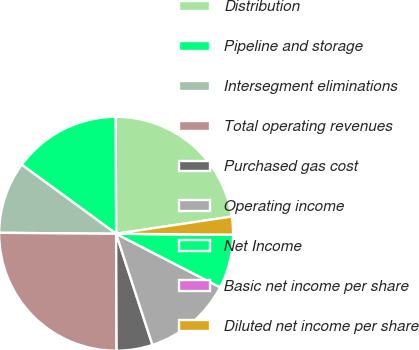<chart> <loc_0><loc_0><loc_500><loc_500><pie_chart><fcel>Distribution<fcel>Pipeline and storage<fcel>Intersegment eliminations<fcel>Total operating revenues<fcel>Purchased gas cost<fcel>Operating income<fcel>Net Income<fcel>Basic net income per share<fcel>Diluted net income per share<nl><fcel>22.72%<fcel>14.88%<fcel>9.92%<fcel>25.2%<fcel>4.96%<fcel>12.4%<fcel>7.44%<fcel>0.0%<fcel>2.48%<nl></chart> 